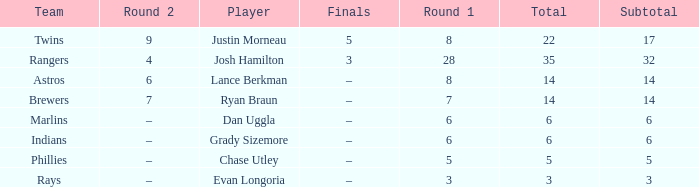Which player has a subtotal of more than 3 and more than 8 in round 1? Josh Hamilton. 